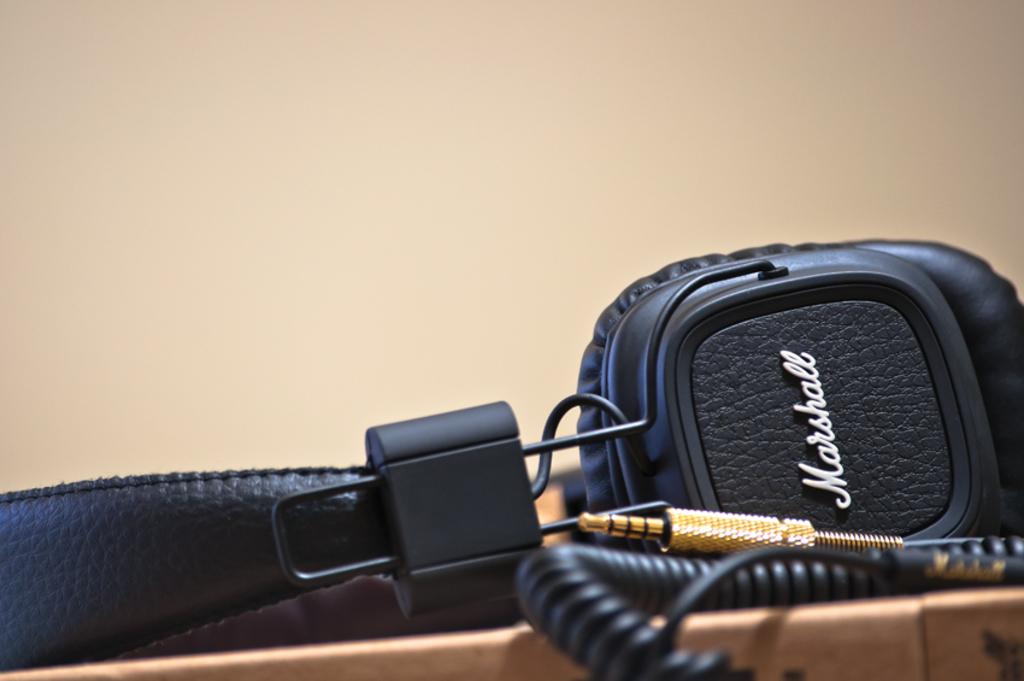What is inside the box in the image? There is an object in a box in the image. What can be seen in the background of the image? There is a wall in the background of the image. What type of mint is growing on the sidewalk in the image? There is no sidewalk or mint present in the image. Is there a birthday celebration happening in the image? There is no indication of a birthday celebration in the image. 